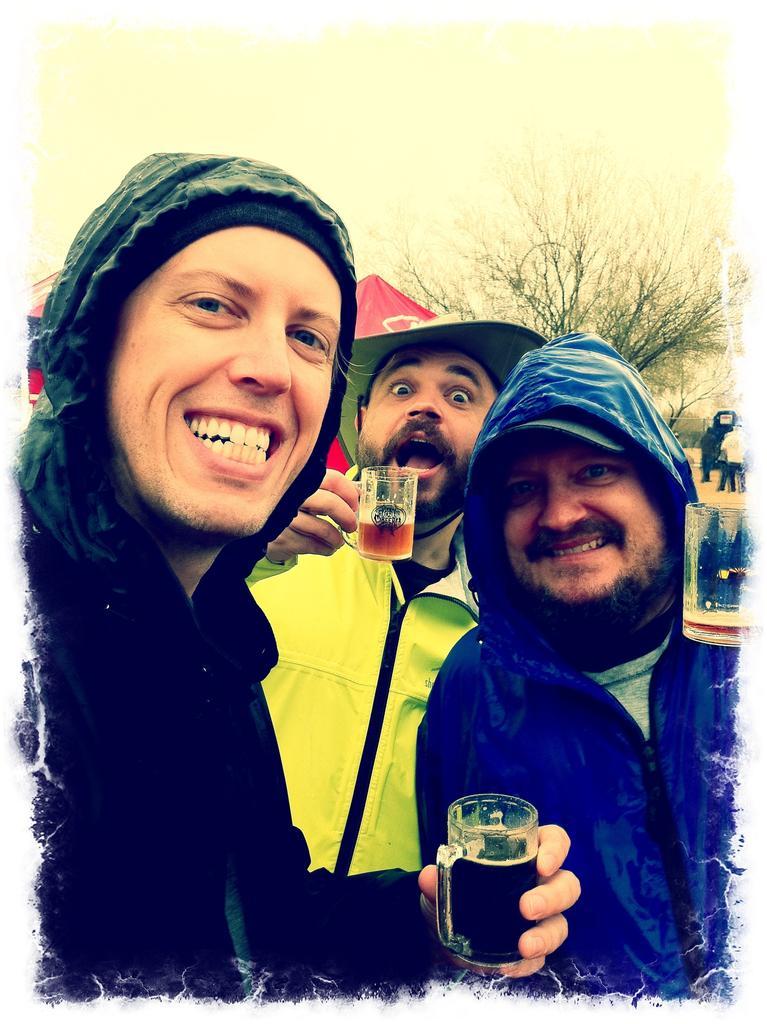Please provide a concise description of this image. In this image there are group of people standing and the background there is building , tree, sky. 